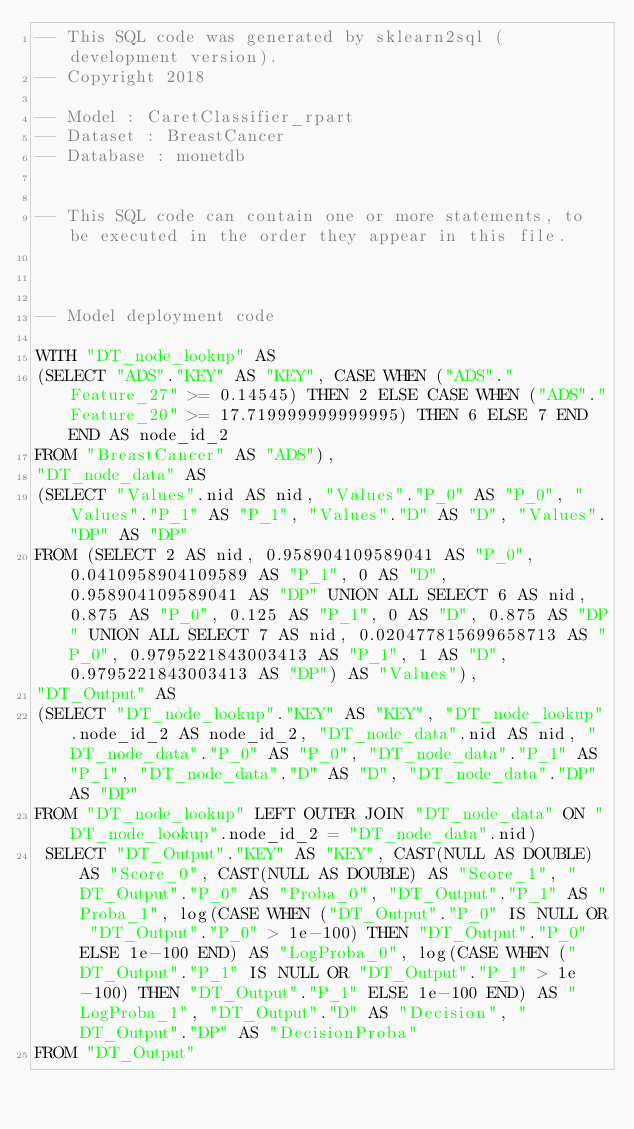Convert code to text. <code><loc_0><loc_0><loc_500><loc_500><_SQL_>-- This SQL code was generated by sklearn2sql (development version).
-- Copyright 2018

-- Model : CaretClassifier_rpart
-- Dataset : BreastCancer
-- Database : monetdb


-- This SQL code can contain one or more statements, to be executed in the order they appear in this file.



-- Model deployment code

WITH "DT_node_lookup" AS 
(SELECT "ADS"."KEY" AS "KEY", CASE WHEN ("ADS"."Feature_27" >= 0.14545) THEN 2 ELSE CASE WHEN ("ADS"."Feature_20" >= 17.719999999999995) THEN 6 ELSE 7 END END AS node_id_2 
FROM "BreastCancer" AS "ADS"), 
"DT_node_data" AS 
(SELECT "Values".nid AS nid, "Values"."P_0" AS "P_0", "Values"."P_1" AS "P_1", "Values"."D" AS "D", "Values"."DP" AS "DP" 
FROM (SELECT 2 AS nid, 0.958904109589041 AS "P_0", 0.0410958904109589 AS "P_1", 0 AS "D", 0.958904109589041 AS "DP" UNION ALL SELECT 6 AS nid, 0.875 AS "P_0", 0.125 AS "P_1", 0 AS "D", 0.875 AS "DP" UNION ALL SELECT 7 AS nid, 0.020477815699658713 AS "P_0", 0.9795221843003413 AS "P_1", 1 AS "D", 0.9795221843003413 AS "DP") AS "Values"), 
"DT_Output" AS 
(SELECT "DT_node_lookup"."KEY" AS "KEY", "DT_node_lookup".node_id_2 AS node_id_2, "DT_node_data".nid AS nid, "DT_node_data"."P_0" AS "P_0", "DT_node_data"."P_1" AS "P_1", "DT_node_data"."D" AS "D", "DT_node_data"."DP" AS "DP" 
FROM "DT_node_lookup" LEFT OUTER JOIN "DT_node_data" ON "DT_node_lookup".node_id_2 = "DT_node_data".nid)
 SELECT "DT_Output"."KEY" AS "KEY", CAST(NULL AS DOUBLE) AS "Score_0", CAST(NULL AS DOUBLE) AS "Score_1", "DT_Output"."P_0" AS "Proba_0", "DT_Output"."P_1" AS "Proba_1", log(CASE WHEN ("DT_Output"."P_0" IS NULL OR "DT_Output"."P_0" > 1e-100) THEN "DT_Output"."P_0" ELSE 1e-100 END) AS "LogProba_0", log(CASE WHEN ("DT_Output"."P_1" IS NULL OR "DT_Output"."P_1" > 1e-100) THEN "DT_Output"."P_1" ELSE 1e-100 END) AS "LogProba_1", "DT_Output"."D" AS "Decision", "DT_Output"."DP" AS "DecisionProba" 
FROM "DT_Output"</code> 